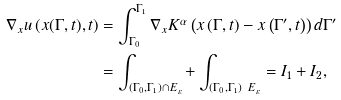<formula> <loc_0><loc_0><loc_500><loc_500>\nabla _ { x } u \left ( x ( \Gamma , t ) , t \right ) & = \int _ { \Gamma _ { 0 } } ^ { \Gamma _ { 1 } } \nabla _ { x } K ^ { \alpha } \left ( x \left ( \Gamma , t \right ) - x \left ( \Gamma ^ { \prime } , t \right ) \right ) d \Gamma ^ { \prime } \\ & = \int _ { \left ( \Gamma _ { 0 } , \Gamma _ { 1 } \right ) \cap E _ { \varepsilon } } + \int _ { \left ( \Gamma _ { 0 } , \Gamma _ { 1 } \right ) \ E _ { \varepsilon } } = I _ { 1 } + I _ { 2 } ,</formula> 